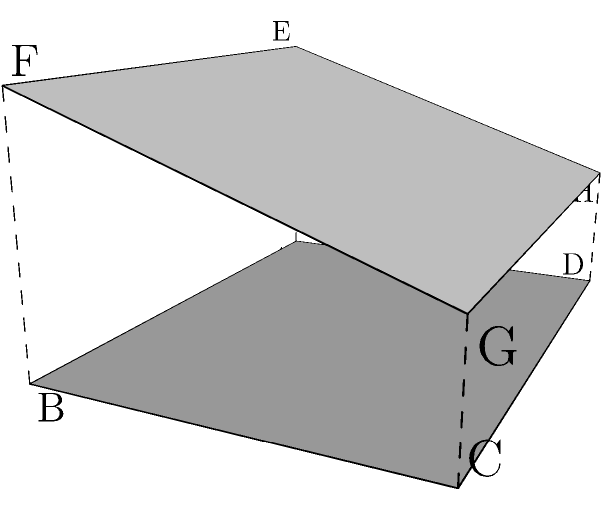During a Grand Slam tennis match, you notice the unique roof design of the stadium. The roof is composed of two planes: ABCD and EFGH. Given that AB = 4 units, BC = 3 units, AE = 2 units, and DH = 1 unit, what is the angle between these two planes? To find the angle between two planes, we need to follow these steps:

1) First, we need to find the normal vectors of both planes.

2) For plane ABCD:
   Vector AB = (4, 0, 0)
   Vector AD = (0, 3, 0)
   Normal vector n1 = AB × AD = (0, 0, 12)

3) For plane EFGH:
   Vector EF = (4, 0, 0)
   Vector EH = (0, 3, -1)
   Normal vector n2 = EF × EH = (3, -4, 12)

4) The angle between the planes is the same as the angle between their normal vectors. We can find this using the dot product formula:

   $$\cos \theta = \frac{n1 \cdot n2}{|n1||n2|}$$

5) Calculating:
   $$n1 \cdot n2 = 0 \cdot 3 + 0 \cdot (-4) + 12 \cdot 12 = 144$$
   $$|n1| = \sqrt{0^2 + 0^2 + 12^2} = 12$$
   $$|n2| = \sqrt{3^2 + (-4)^2 + 12^2} = 13$$

6) Substituting into the formula:
   $$\cos \theta = \frac{144}{12 \cdot 13} = \frac{12}{13}$$

7) Taking the inverse cosine (arccos) of both sides:
   $$\theta = \arccos(\frac{12}{13})$$

8) Calculate the result:
   $$\theta \approx 22.6°$$
Answer: $22.6°$ 